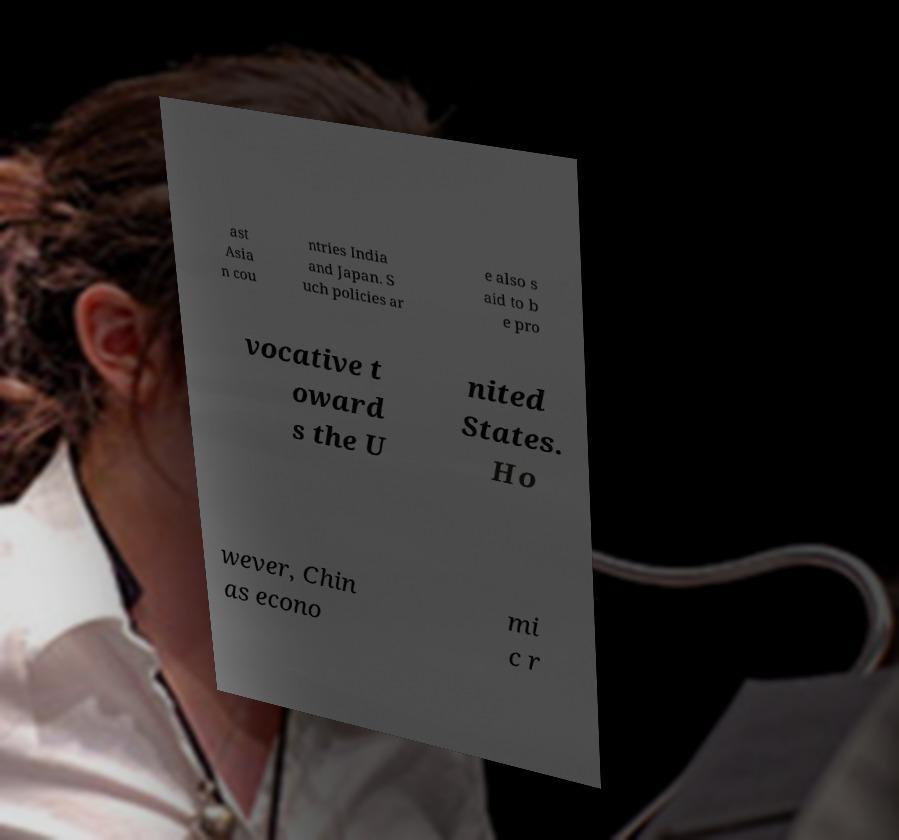For documentation purposes, I need the text within this image transcribed. Could you provide that? ast Asia n cou ntries India and Japan. S uch policies ar e also s aid to b e pro vocative t oward s the U nited States. Ho wever, Chin as econo mi c r 